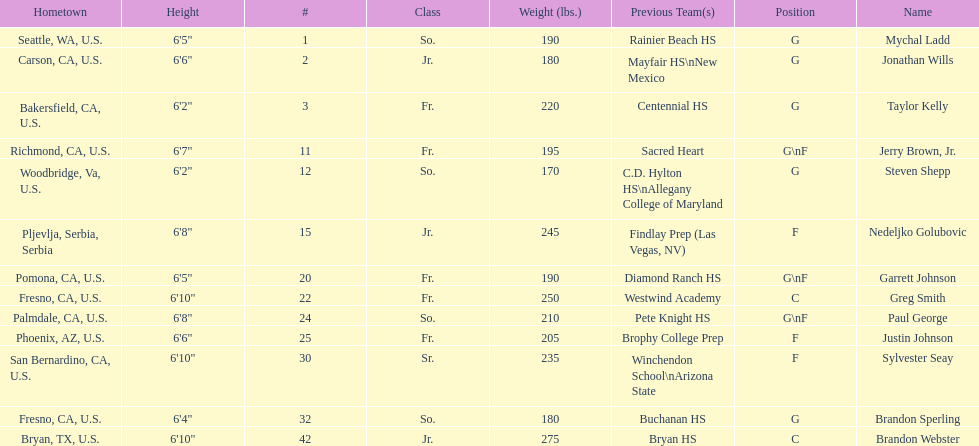How many players and both guard (g) and forward (f)? 3. Could you parse the entire table as a dict? {'header': ['Hometown', 'Height', '#', 'Class', 'Weight (lbs.)', 'Previous Team(s)', 'Position', 'Name'], 'rows': [['Seattle, WA, U.S.', '6\'5"', '1', 'So.', '190', 'Rainier Beach HS', 'G', 'Mychal Ladd'], ['Carson, CA, U.S.', '6\'6"', '2', 'Jr.', '180', 'Mayfair HS\\nNew Mexico', 'G', 'Jonathan Wills'], ['Bakersfield, CA, U.S.', '6\'2"', '3', 'Fr.', '220', 'Centennial HS', 'G', 'Taylor Kelly'], ['Richmond, CA, U.S.', '6\'7"', '11', 'Fr.', '195', 'Sacred Heart', 'G\\nF', 'Jerry Brown, Jr.'], ['Woodbridge, Va, U.S.', '6\'2"', '12', 'So.', '170', 'C.D. Hylton HS\\nAllegany College of Maryland', 'G', 'Steven Shepp'], ['Pljevlja, Serbia, Serbia', '6\'8"', '15', 'Jr.', '245', 'Findlay Prep (Las Vegas, NV)', 'F', 'Nedeljko Golubovic'], ['Pomona, CA, U.S.', '6\'5"', '20', 'Fr.', '190', 'Diamond Ranch HS', 'G\\nF', 'Garrett Johnson'], ['Fresno, CA, U.S.', '6\'10"', '22', 'Fr.', '250', 'Westwind Academy', 'C', 'Greg Smith'], ['Palmdale, CA, U.S.', '6\'8"', '24', 'So.', '210', 'Pete Knight HS', 'G\\nF', 'Paul George'], ['Phoenix, AZ, U.S.', '6\'6"', '25', 'Fr.', '205', 'Brophy College Prep', 'F', 'Justin Johnson'], ['San Bernardino, CA, U.S.', '6\'10"', '30', 'Sr.', '235', 'Winchendon School\\nArizona State', 'F', 'Sylvester Seay'], ['Fresno, CA, U.S.', '6\'4"', '32', 'So.', '180', 'Buchanan HS', 'G', 'Brandon Sperling'], ['Bryan, TX, U.S.', '6\'10"', '42', 'Jr.', '275', 'Bryan HS', 'C', 'Brandon Webster']]} 